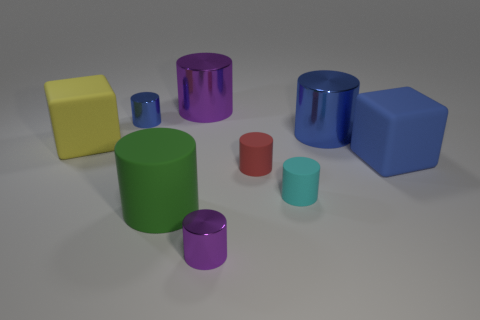Subtract all big purple cylinders. How many cylinders are left? 6 Add 1 big things. How many objects exist? 10 Subtract all yellow cubes. How many blue cylinders are left? 2 Subtract all green cylinders. How many cylinders are left? 6 Subtract all cubes. How many objects are left? 7 Subtract 1 blue blocks. How many objects are left? 8 Subtract 2 cubes. How many cubes are left? 0 Subtract all cyan cylinders. Subtract all purple cubes. How many cylinders are left? 6 Subtract all large blue matte blocks. Subtract all tiny metal cylinders. How many objects are left? 6 Add 9 small red rubber cylinders. How many small red rubber cylinders are left? 10 